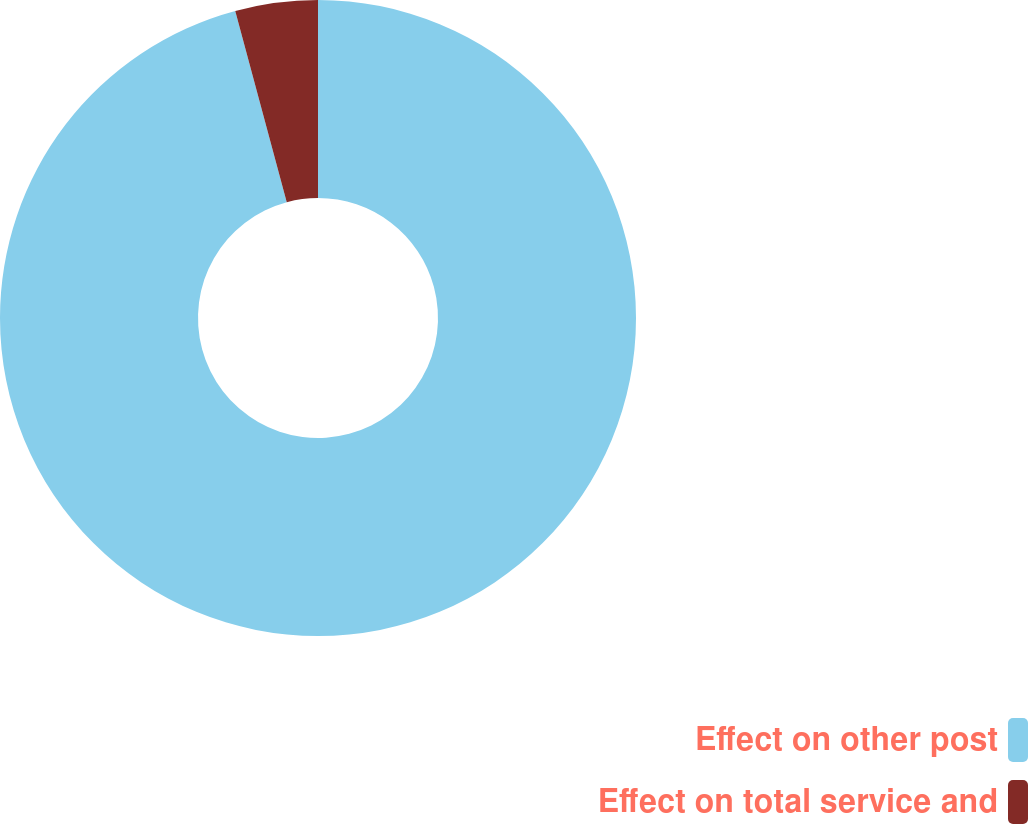Convert chart to OTSL. <chart><loc_0><loc_0><loc_500><loc_500><pie_chart><fcel>Effect on other post<fcel>Effect on total service and<nl><fcel>95.81%<fcel>4.19%<nl></chart> 